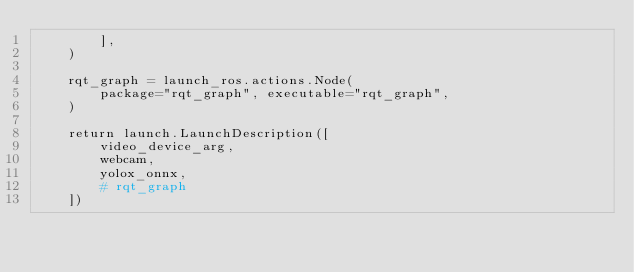<code> <loc_0><loc_0><loc_500><loc_500><_Python_>        ],
    )

    rqt_graph = launch_ros.actions.Node(
        package="rqt_graph", executable="rqt_graph",
    )

    return launch.LaunchDescription([
        video_device_arg,
        webcam,
        yolox_onnx,
        # rqt_graph
    ])</code> 